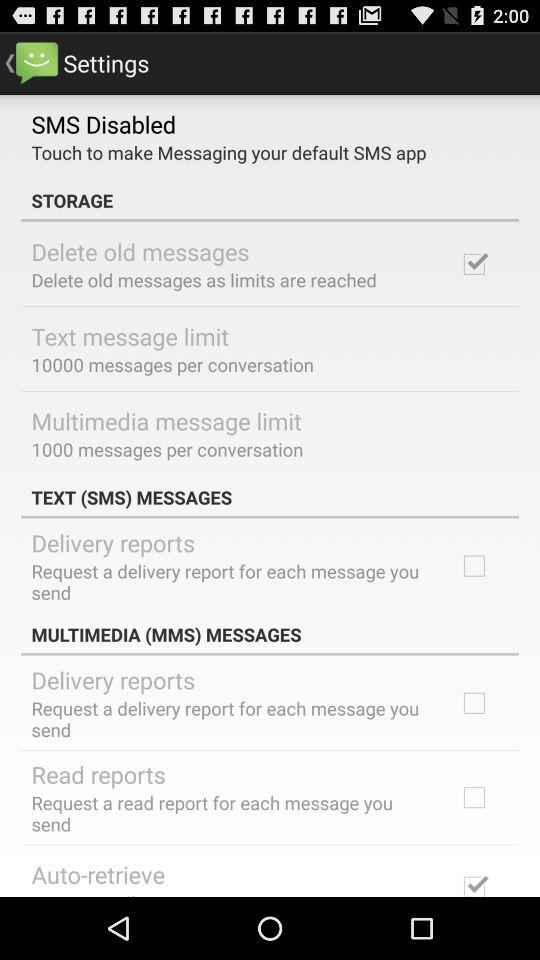Which settings are checked? The checked settings are "Delete old messages" and "Auto-retrieve". 